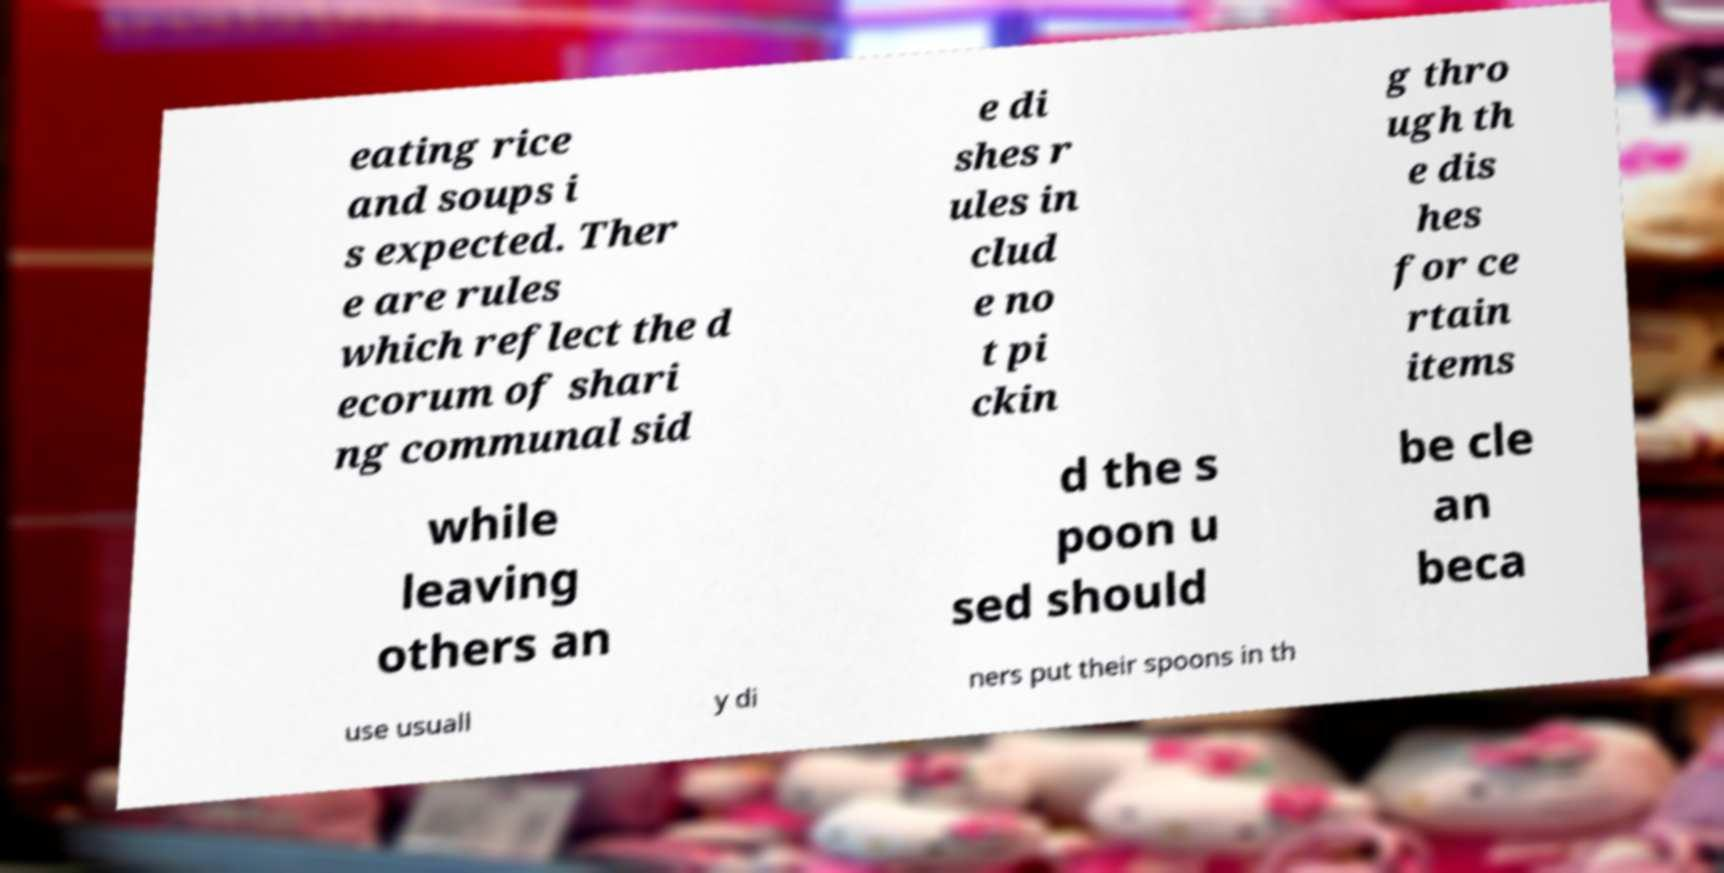For documentation purposes, I need the text within this image transcribed. Could you provide that? eating rice and soups i s expected. Ther e are rules which reflect the d ecorum of shari ng communal sid e di shes r ules in clud e no t pi ckin g thro ugh th e dis hes for ce rtain items while leaving others an d the s poon u sed should be cle an beca use usuall y di ners put their spoons in th 